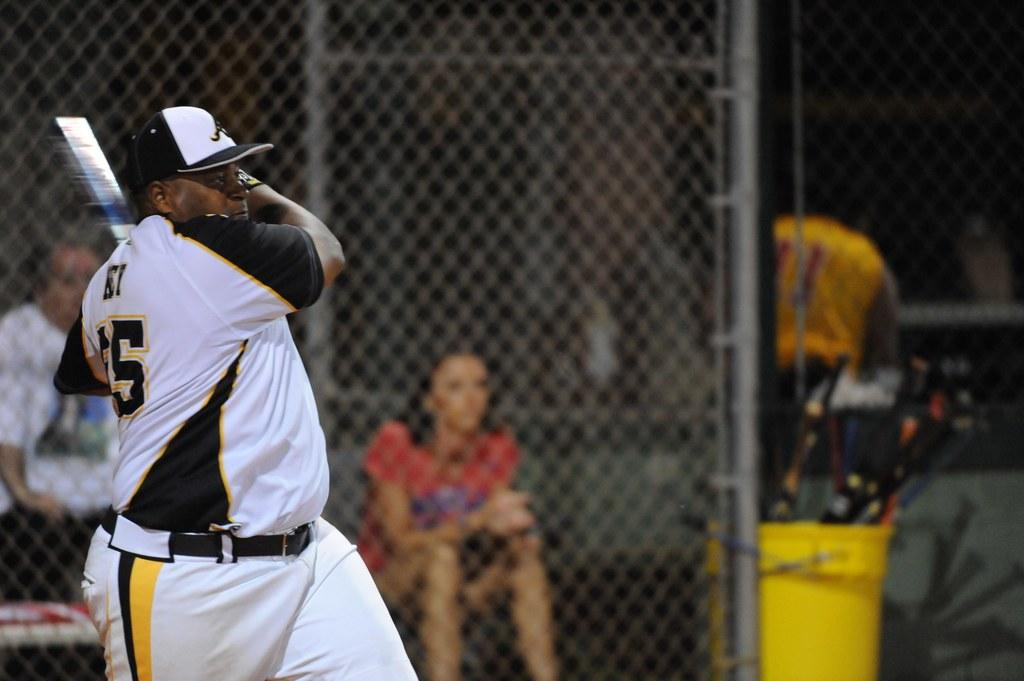<image>
Provide a brief description of the given image. the number 5 is on the white jersey 